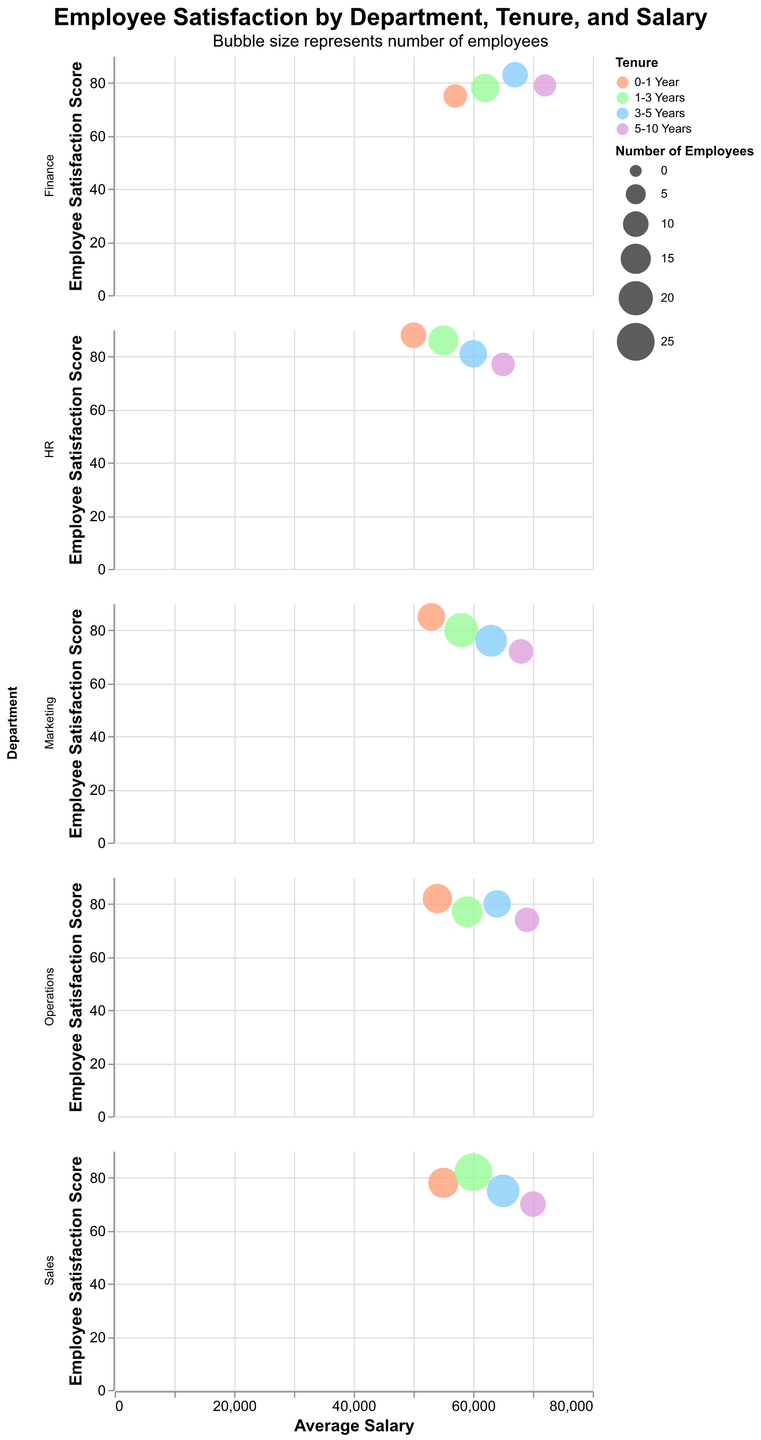What's the title of the figure? The title is displayed at the top of the figure, and it reads "Employee Satisfaction by Department, Tenure, and Salary".
Answer: Employee Satisfaction by Department, Tenure, and Salary What does the color of the bubbles represent? The legend shows that the color of the bubbles represents the tenure of employees, with different colors for "0-1 Year," "1-3 Years," "3-5 Years," and "5-10 Years".
Answer: Tenure Which department has the highest employee satisfaction for new employees (0-1 Year)? By looking at the subplot for each department and checking the color representing "0-1 Year," we can see that the HR department has the highest satisfaction score of 88 for new employees.
Answer: HR What is the average salary for employees with 5-10 years of tenure in Sales? In the Sales subplot, locate the bubble colored for "5-10 Years" and check the x-axis value, which indicates the average salary. It's $70,000.
Answer: $70,000 Which department has the largest bubble for 1-3 years of tenure, and what does that indicate? The largest bubble for 1-3 years of tenure appears in the Sales subplot, which indicates that Sales has the highest number of employees (25) with 1-3 years of tenure.
Answer: Sales, highest number of employees How does employee satisfaction change with increasing average salary in the Marketing department? Observing the Marketing subplot, as the average salary increases, employee satisfaction decreases from 85 to 72.
Answer: Decreases Which tenure group in Finance has the highest employee satisfaction score and what is the score? In the Finance subplot, the bubble with the highest employee satisfaction score (83) corresponds to employees with 3-5 years of tenure.
Answer: 3-5 Years, 83 Compare the average salaries for employees with 3-5 years of tenure in HR and Operations. Which is higher and by how much? In the HR and Operations subplots, find the average salary for the "3-5 Years" tenure group. HR has $60,000 and Operations has $64,000. The Operations average salary is higher by $4,000.
Answer: Operations, $4,000 What is the employee satisfaction score and number of employees for the lowest-scoring tenure group in Operations? In the Operations subplot, find the bubble with the lowest satisfaction score. For 5-10 Years tenure, the satisfaction score is 74, and there are 9 employees.
Answer: 74, 9 Which department has a more significant difference in employee satisfaction scores between 0-1 year and 5-10 years of tenure, Sales or Marketing? In the Sales subplot, the satisfaction scores are 78 (0-1 Year) and 70 (5-10 Years), a difference of 8. In the Marketing subplot, the scores are 85 (0-1 Year) and 72 (5-10 Years), a difference of 13. Marketing has a more significant difference.
Answer: Marketing, 13 